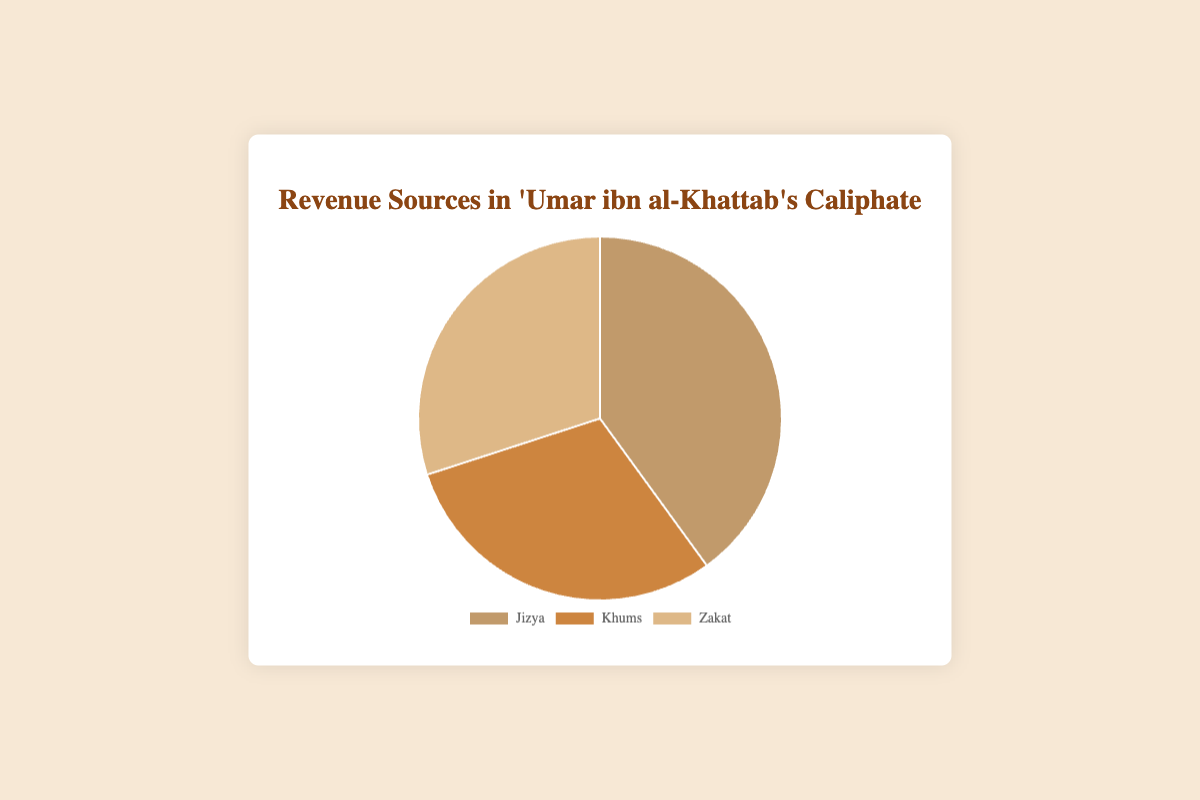Which source of revenue contributes the highest percentage in 'Umar ibn al-Khattab's Caliphate? By looking at the pie chart, the largest segment represents Jizya, which is 40%. Therefore, Jizya is the highest source of revenue.
Answer: Jizya How many percentage points higher is Jizya compared to Khums? The chart shows that Jizya is 40% and Khums is 30%. The difference can be calculated as 40% - 30% = 10%.
Answer: 10% What is the total percentage contribution of Khums and Zakat combined? From the pie chart, Khums is 30% and Zakat is 30%. Adding these together gives 30% + 30% = 60%.
Answer: 60% Which sources of revenue contribute equally to the total revenue? The segments of the pie chart show that Khums and Zakat each contribute 30%. Therefore, their contributions are equal.
Answer: Khums and Zakat If Zakat and Jizya are combined, what percentage of the total revenue do they represent? The chart indicates that Zakat is 30% and Jizya is 40%. Adding these two figures gives 30% + 40% = 70%.
Answer: 70% By how many percentage points does the largest revenue source exceed the smallest? The largest revenue source, Jizya, is 40%, and the smallest, either Khums or Zakat, is 30%. The difference is 40% - 30% = 10%.
Answer: 10% If the contribution of Jizya decreased by 5 percentage points, how much would it be? Initially, Jizya is 40%. If it decreases by 5 percentage points, the new contribution will be 40% - 5% = 35%.
Answer: 35% What fraction of the total revenue is contributed by Khums? Khums represents 30% of the total revenue. To convert this to a fraction, we have 30/100 = 3/10.
Answer: 3/10 